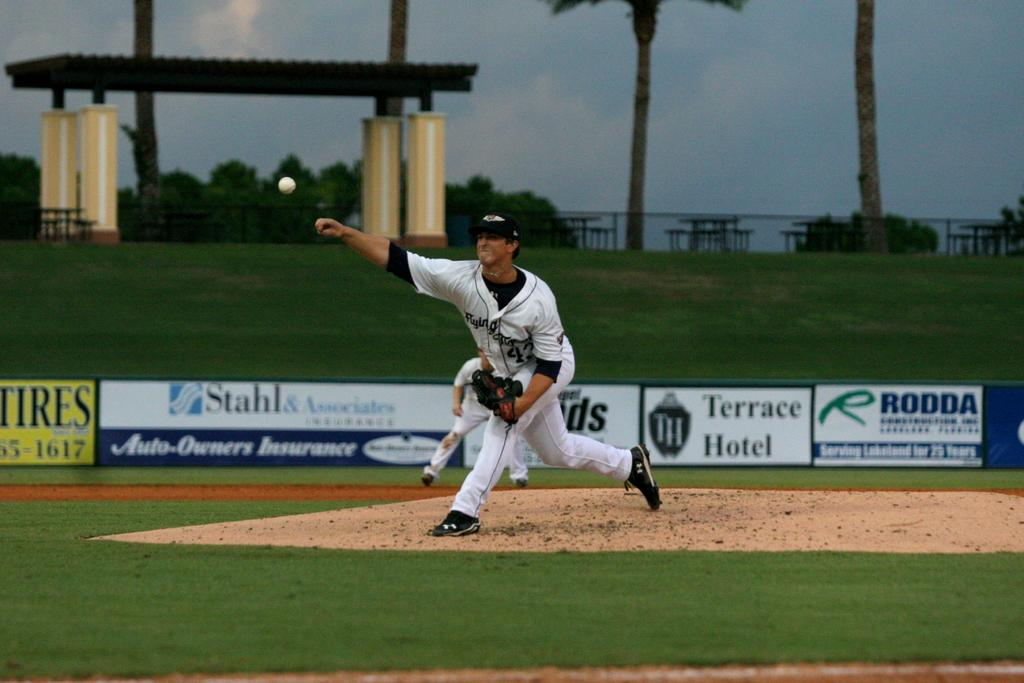<image>
Create a compact narrative representing the image presented. A baseball pitcher in motion with the home run fence made of ads for insurance and a hotel. 